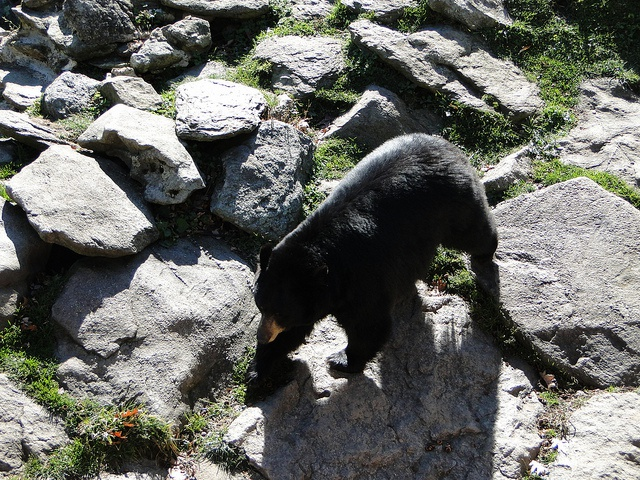Describe the objects in this image and their specific colors. I can see a bear in black, gray, darkgray, and lightgray tones in this image. 